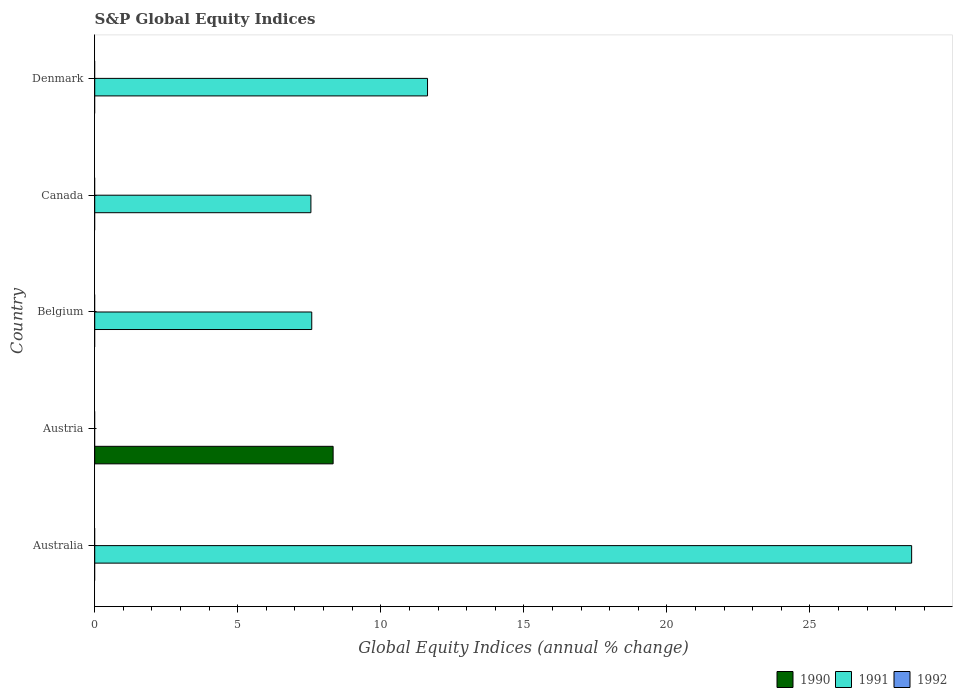Are the number of bars per tick equal to the number of legend labels?
Keep it short and to the point. No. Are the number of bars on each tick of the Y-axis equal?
Provide a short and direct response. Yes. How many bars are there on the 3rd tick from the bottom?
Give a very brief answer. 1. What is the label of the 5th group of bars from the top?
Your response must be concise. Australia. In how many cases, is the number of bars for a given country not equal to the number of legend labels?
Provide a short and direct response. 5. What is the global equity indices in 1992 in Canada?
Ensure brevity in your answer.  0. Across all countries, what is the maximum global equity indices in 1990?
Provide a short and direct response. 8.33. In which country was the global equity indices in 1990 maximum?
Keep it short and to the point. Austria. What is the total global equity indices in 1991 in the graph?
Give a very brief answer. 55.33. What is the difference between the global equity indices in 1991 in Australia and that in Belgium?
Give a very brief answer. 20.97. What is the difference between the global equity indices in 1992 in Canada and the global equity indices in 1990 in Belgium?
Provide a short and direct response. 0. What is the average global equity indices in 1992 per country?
Offer a terse response. 0. In how many countries, is the global equity indices in 1991 greater than 15 %?
Offer a very short reply. 1. What is the ratio of the global equity indices in 1991 in Belgium to that in Canada?
Offer a terse response. 1. What is the difference between the highest and the second highest global equity indices in 1991?
Ensure brevity in your answer.  16.92. What is the difference between the highest and the lowest global equity indices in 1990?
Make the answer very short. 8.33. In how many countries, is the global equity indices in 1991 greater than the average global equity indices in 1991 taken over all countries?
Provide a succinct answer. 2. Is it the case that in every country, the sum of the global equity indices in 1990 and global equity indices in 1991 is greater than the global equity indices in 1992?
Provide a succinct answer. Yes. How many bars are there?
Ensure brevity in your answer.  5. How many countries are there in the graph?
Your answer should be compact. 5. What is the difference between two consecutive major ticks on the X-axis?
Offer a terse response. 5. Does the graph contain grids?
Give a very brief answer. No. Where does the legend appear in the graph?
Ensure brevity in your answer.  Bottom right. How many legend labels are there?
Your answer should be very brief. 3. How are the legend labels stacked?
Offer a terse response. Horizontal. What is the title of the graph?
Offer a terse response. S&P Global Equity Indices. What is the label or title of the X-axis?
Provide a succinct answer. Global Equity Indices (annual % change). What is the Global Equity Indices (annual % change) of 1990 in Australia?
Your answer should be very brief. 0. What is the Global Equity Indices (annual % change) in 1991 in Australia?
Your response must be concise. 28.56. What is the Global Equity Indices (annual % change) in 1990 in Austria?
Keep it short and to the point. 8.33. What is the Global Equity Indices (annual % change) in 1990 in Belgium?
Offer a terse response. 0. What is the Global Equity Indices (annual % change) of 1991 in Belgium?
Offer a terse response. 7.59. What is the Global Equity Indices (annual % change) of 1992 in Belgium?
Your answer should be compact. 0. What is the Global Equity Indices (annual % change) of 1991 in Canada?
Give a very brief answer. 7.56. What is the Global Equity Indices (annual % change) of 1992 in Canada?
Your answer should be compact. 0. What is the Global Equity Indices (annual % change) in 1991 in Denmark?
Give a very brief answer. 11.63. Across all countries, what is the maximum Global Equity Indices (annual % change) of 1990?
Give a very brief answer. 8.33. Across all countries, what is the maximum Global Equity Indices (annual % change) of 1991?
Keep it short and to the point. 28.56. What is the total Global Equity Indices (annual % change) of 1990 in the graph?
Your response must be concise. 8.33. What is the total Global Equity Indices (annual % change) in 1991 in the graph?
Provide a short and direct response. 55.33. What is the total Global Equity Indices (annual % change) of 1992 in the graph?
Your answer should be very brief. 0. What is the difference between the Global Equity Indices (annual % change) in 1991 in Australia and that in Belgium?
Your response must be concise. 20.97. What is the difference between the Global Equity Indices (annual % change) in 1991 in Australia and that in Canada?
Your answer should be very brief. 21. What is the difference between the Global Equity Indices (annual % change) of 1991 in Australia and that in Denmark?
Offer a terse response. 16.92. What is the difference between the Global Equity Indices (annual % change) in 1991 in Belgium and that in Canada?
Give a very brief answer. 0.03. What is the difference between the Global Equity Indices (annual % change) of 1991 in Belgium and that in Denmark?
Offer a very short reply. -4.05. What is the difference between the Global Equity Indices (annual % change) in 1991 in Canada and that in Denmark?
Keep it short and to the point. -4.08. What is the difference between the Global Equity Indices (annual % change) in 1990 in Austria and the Global Equity Indices (annual % change) in 1991 in Belgium?
Your answer should be very brief. 0.75. What is the difference between the Global Equity Indices (annual % change) of 1990 in Austria and the Global Equity Indices (annual % change) of 1991 in Canada?
Ensure brevity in your answer.  0.78. What is the difference between the Global Equity Indices (annual % change) of 1990 in Austria and the Global Equity Indices (annual % change) of 1991 in Denmark?
Provide a succinct answer. -3.3. What is the average Global Equity Indices (annual % change) in 1990 per country?
Your response must be concise. 1.67. What is the average Global Equity Indices (annual % change) in 1991 per country?
Your answer should be compact. 11.07. What is the average Global Equity Indices (annual % change) of 1992 per country?
Make the answer very short. 0. What is the ratio of the Global Equity Indices (annual % change) of 1991 in Australia to that in Belgium?
Your answer should be compact. 3.76. What is the ratio of the Global Equity Indices (annual % change) of 1991 in Australia to that in Canada?
Your answer should be compact. 3.78. What is the ratio of the Global Equity Indices (annual % change) of 1991 in Australia to that in Denmark?
Offer a very short reply. 2.45. What is the ratio of the Global Equity Indices (annual % change) in 1991 in Belgium to that in Canada?
Ensure brevity in your answer.  1. What is the ratio of the Global Equity Indices (annual % change) in 1991 in Belgium to that in Denmark?
Provide a succinct answer. 0.65. What is the ratio of the Global Equity Indices (annual % change) in 1991 in Canada to that in Denmark?
Offer a very short reply. 0.65. What is the difference between the highest and the second highest Global Equity Indices (annual % change) of 1991?
Keep it short and to the point. 16.92. What is the difference between the highest and the lowest Global Equity Indices (annual % change) of 1990?
Give a very brief answer. 8.33. What is the difference between the highest and the lowest Global Equity Indices (annual % change) in 1991?
Provide a succinct answer. 28.56. 